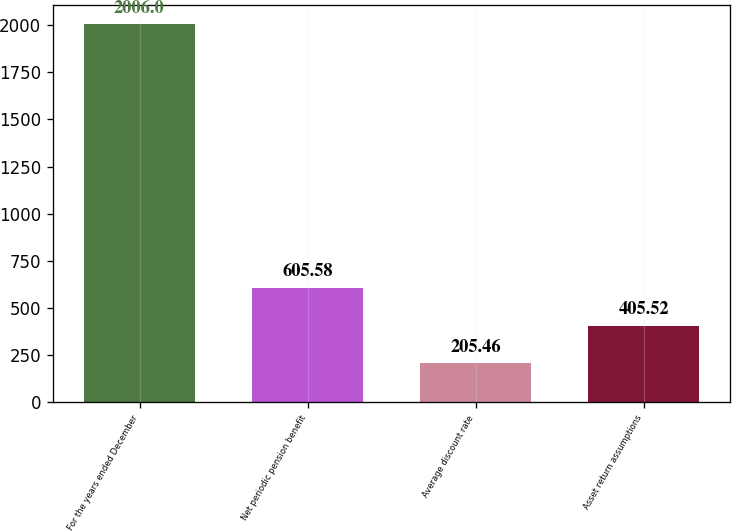Convert chart. <chart><loc_0><loc_0><loc_500><loc_500><bar_chart><fcel>For the years ended December<fcel>Net periodic pension benefit<fcel>Average discount rate<fcel>Asset return assumptions<nl><fcel>2006<fcel>605.58<fcel>205.46<fcel>405.52<nl></chart> 